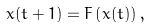<formula> <loc_0><loc_0><loc_500><loc_500>x ( t + 1 ) = F \left ( x ( t ) \right ) ,</formula> 